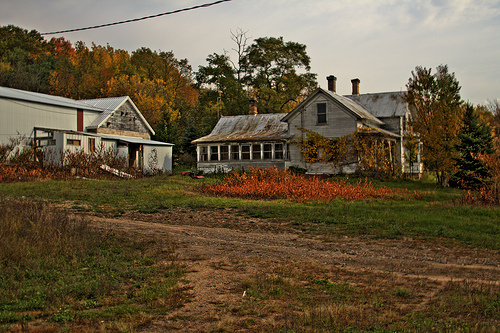<image>
Is the tree next to the sky? No. The tree is not positioned next to the sky. They are located in different areas of the scene. Is the trees in front of the sky? Yes. The trees is positioned in front of the sky, appearing closer to the camera viewpoint. 